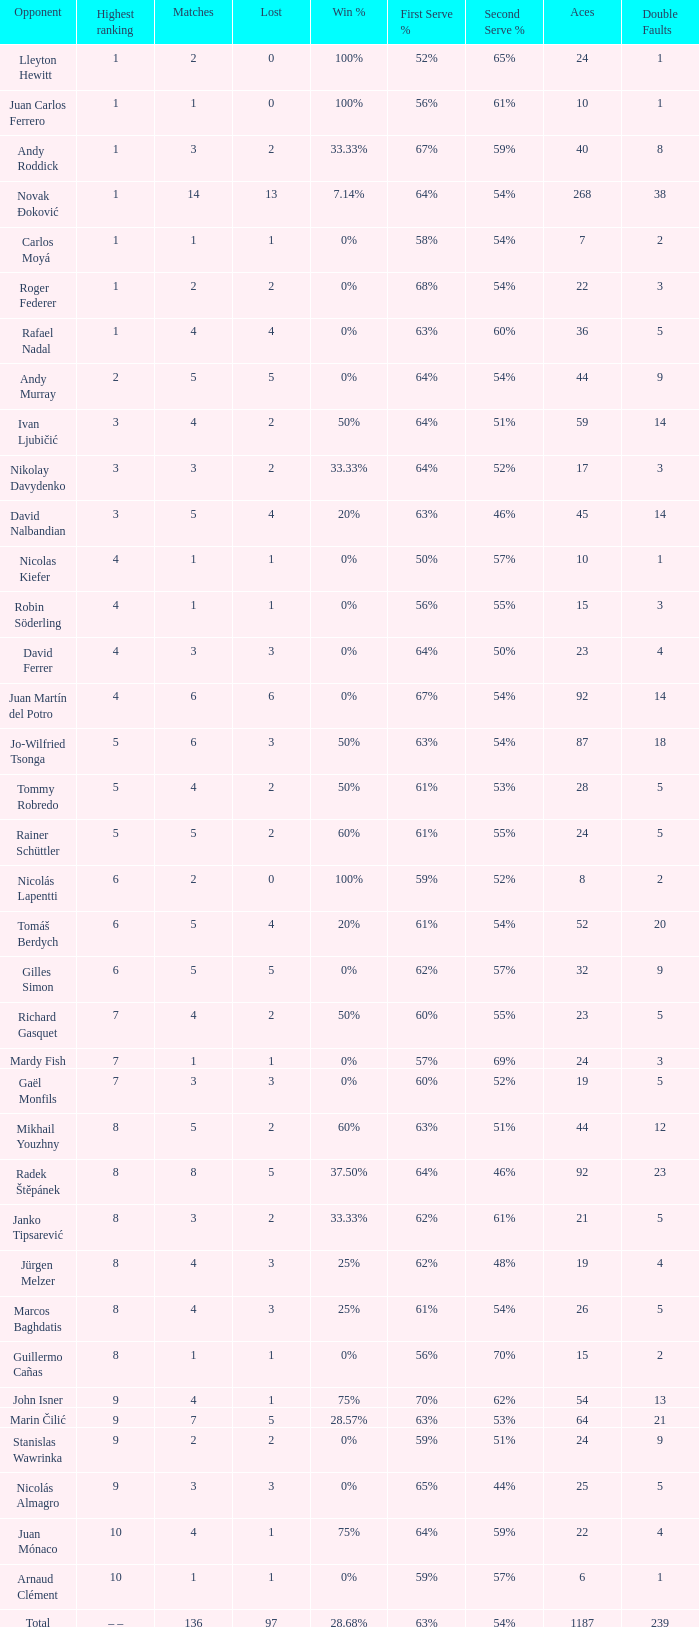What is the total number of Lost for the Highest Ranking of – –? 1.0. 